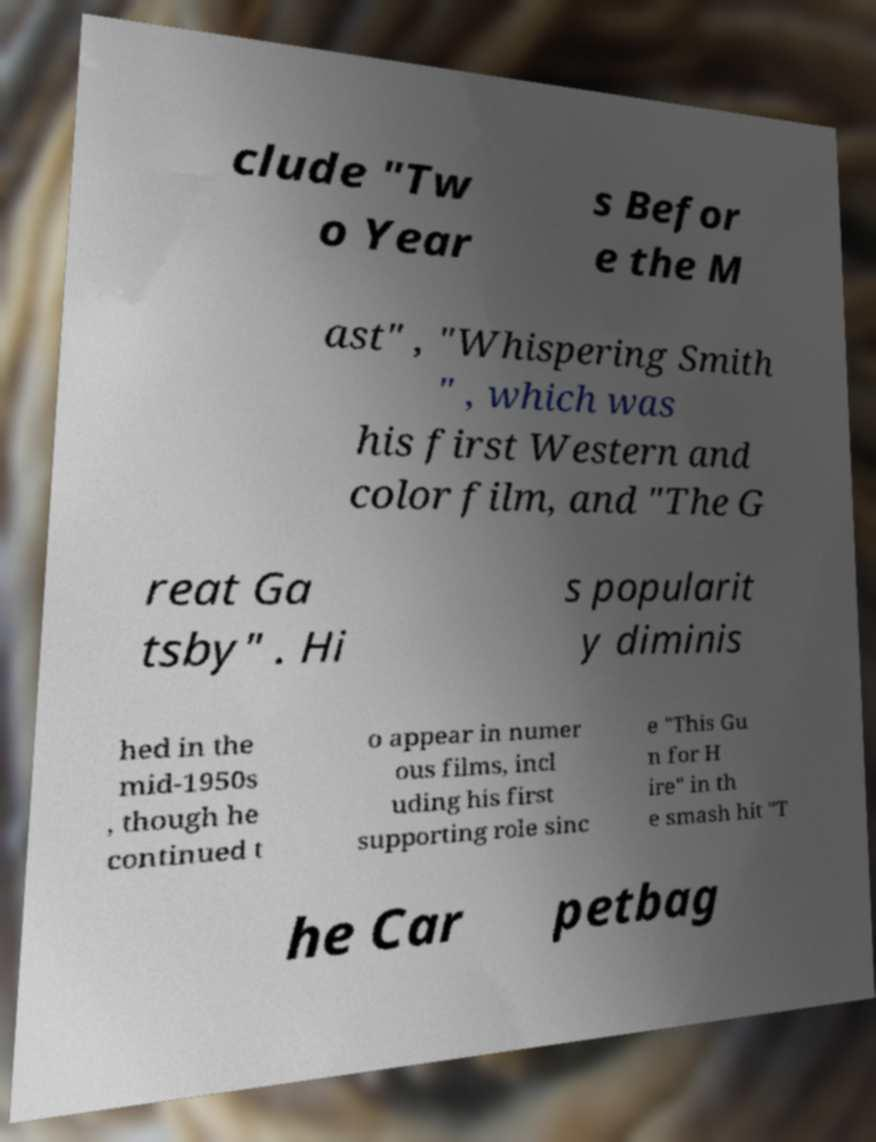Can you read and provide the text displayed in the image?This photo seems to have some interesting text. Can you extract and type it out for me? clude "Tw o Year s Befor e the M ast" , "Whispering Smith " , which was his first Western and color film, and "The G reat Ga tsby" . Hi s popularit y diminis hed in the mid-1950s , though he continued t o appear in numer ous films, incl uding his first supporting role sinc e "This Gu n for H ire" in th e smash hit "T he Car petbag 